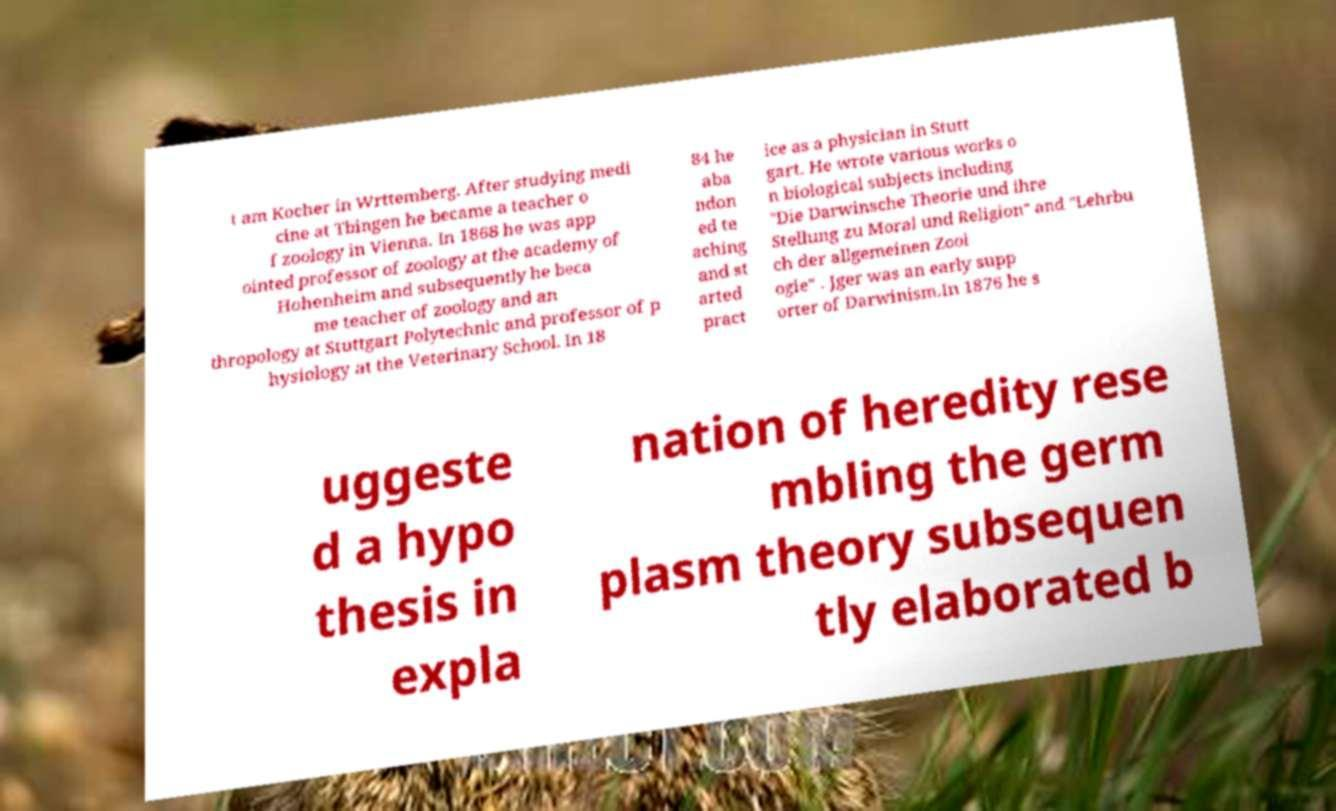Could you extract and type out the text from this image? t am Kocher in Wrttemberg. After studying medi cine at Tbingen he became a teacher o f zoology in Vienna. In 1868 he was app ointed professor of zoology at the academy of Hohenheim and subsequently he beca me teacher of zoology and an thropology at Stuttgart Polytechnic and professor of p hysiology at the Veterinary School. In 18 84 he aba ndon ed te aching and st arted pract ice as a physician in Stutt gart. He wrote various works o n biological subjects including "Die Darwinsche Theorie und ihre Stellung zu Moral und Religion" and "Lehrbu ch der allgemeinen Zool ogie" . Jger was an early supp orter of Darwinism.In 1876 he s uggeste d a hypo thesis in expla nation of heredity rese mbling the germ plasm theory subsequen tly elaborated b 